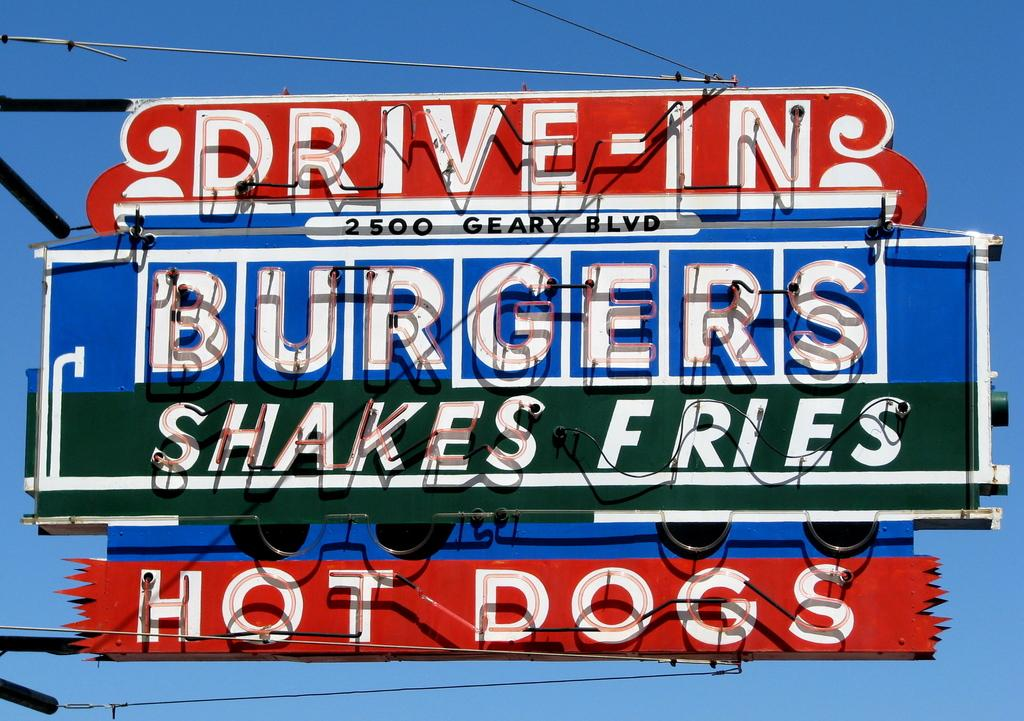<image>
Offer a succinct explanation of the picture presented. Sign for Drive-in burgers on 2500 Geary Blvd. 